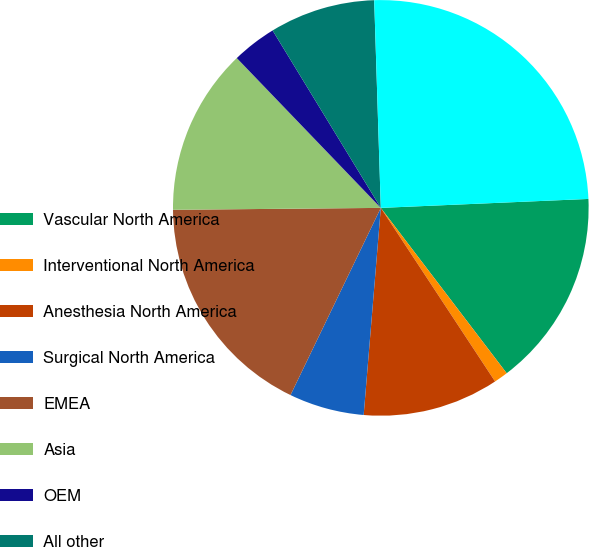Convert chart to OTSL. <chart><loc_0><loc_0><loc_500><loc_500><pie_chart><fcel>Vascular North America<fcel>Interventional North America<fcel>Anesthesia North America<fcel>Surgical North America<fcel>EMEA<fcel>Asia<fcel>OEM<fcel>All other<fcel>Segment Net Revenues<nl><fcel>15.33%<fcel>1.09%<fcel>10.58%<fcel>5.84%<fcel>17.7%<fcel>12.96%<fcel>3.47%<fcel>8.21%<fcel>24.82%<nl></chart> 